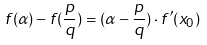<formula> <loc_0><loc_0><loc_500><loc_500>f ( \alpha ) - f ( { \frac { p } { q } } ) = ( \alpha - { \frac { p } { q } } ) \cdot f ^ { \prime } ( x _ { 0 } )</formula> 